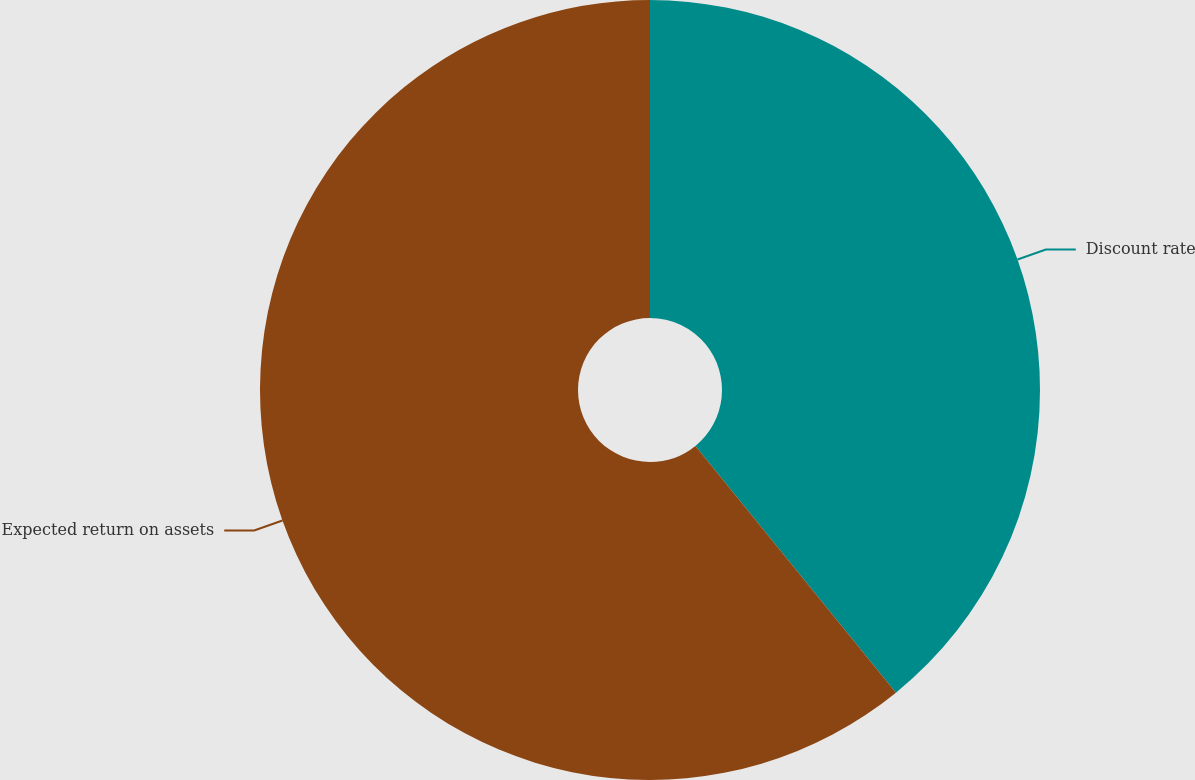Convert chart. <chart><loc_0><loc_0><loc_500><loc_500><pie_chart><fcel>Discount rate<fcel>Expected return on assets<nl><fcel>39.14%<fcel>60.86%<nl></chart> 